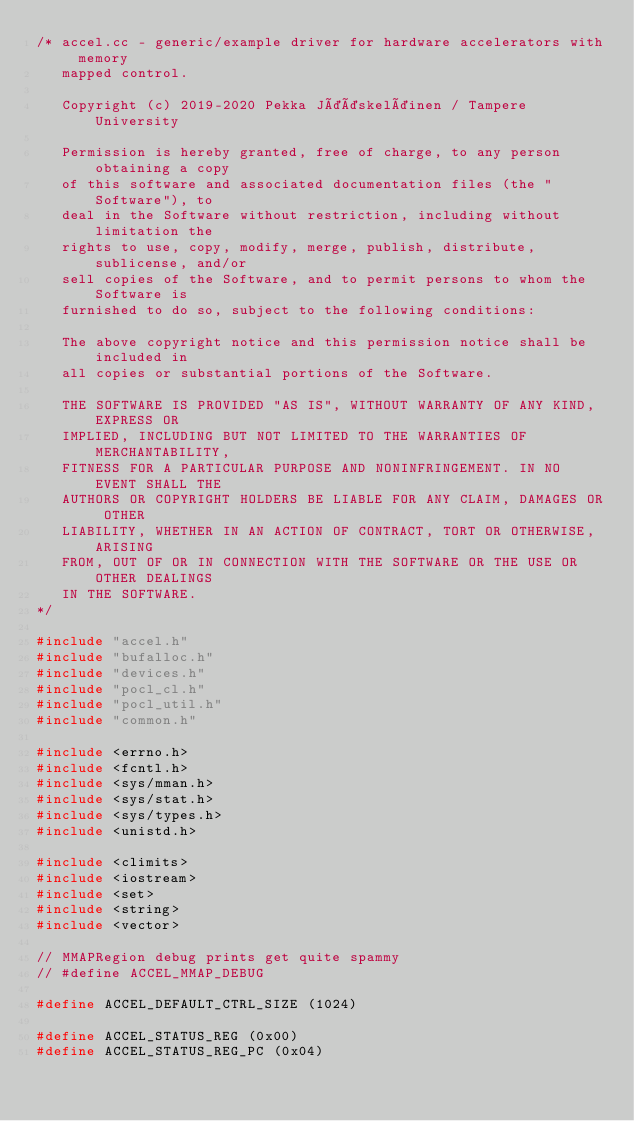Convert code to text. <code><loc_0><loc_0><loc_500><loc_500><_C++_>/* accel.cc - generic/example driver for hardware accelerators with memory
   mapped control.

   Copyright (c) 2019-2020 Pekka Jääskeläinen / Tampere University

   Permission is hereby granted, free of charge, to any person obtaining a copy
   of this software and associated documentation files (the "Software"), to
   deal in the Software without restriction, including without limitation the
   rights to use, copy, modify, merge, publish, distribute, sublicense, and/or
   sell copies of the Software, and to permit persons to whom the Software is
   furnished to do so, subject to the following conditions:

   The above copyright notice and this permission notice shall be included in
   all copies or substantial portions of the Software.

   THE SOFTWARE IS PROVIDED "AS IS", WITHOUT WARRANTY OF ANY KIND, EXPRESS OR
   IMPLIED, INCLUDING BUT NOT LIMITED TO THE WARRANTIES OF MERCHANTABILITY,
   FITNESS FOR A PARTICULAR PURPOSE AND NONINFRINGEMENT. IN NO EVENT SHALL THE
   AUTHORS OR COPYRIGHT HOLDERS BE LIABLE FOR ANY CLAIM, DAMAGES OR OTHER
   LIABILITY, WHETHER IN AN ACTION OF CONTRACT, TORT OR OTHERWISE, ARISING
   FROM, OUT OF OR IN CONNECTION WITH THE SOFTWARE OR THE USE OR OTHER DEALINGS
   IN THE SOFTWARE.
*/

#include "accel.h"
#include "bufalloc.h"
#include "devices.h"
#include "pocl_cl.h"
#include "pocl_util.h"
#include "common.h"

#include <errno.h>
#include <fcntl.h>
#include <sys/mman.h>
#include <sys/stat.h>
#include <sys/types.h>
#include <unistd.h>

#include <climits>
#include <iostream>
#include <set>
#include <string>
#include <vector>

// MMAPRegion debug prints get quite spammy
// #define ACCEL_MMAP_DEBUG

#define ACCEL_DEFAULT_CTRL_SIZE (1024)

#define ACCEL_STATUS_REG (0x00)
#define ACCEL_STATUS_REG_PC (0x04)</code> 